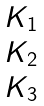Convert formula to latex. <formula><loc_0><loc_0><loc_500><loc_500>\begin{matrix} K _ { 1 } \\ K _ { 2 } \\ K _ { 3 } \end{matrix}</formula> 